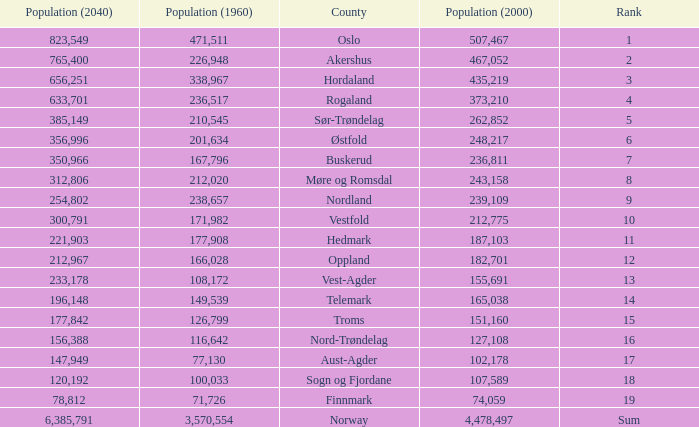What was the population of a county in 1960 that had a population of 467,052 in 2000 and 78,812 in 2040? None. 